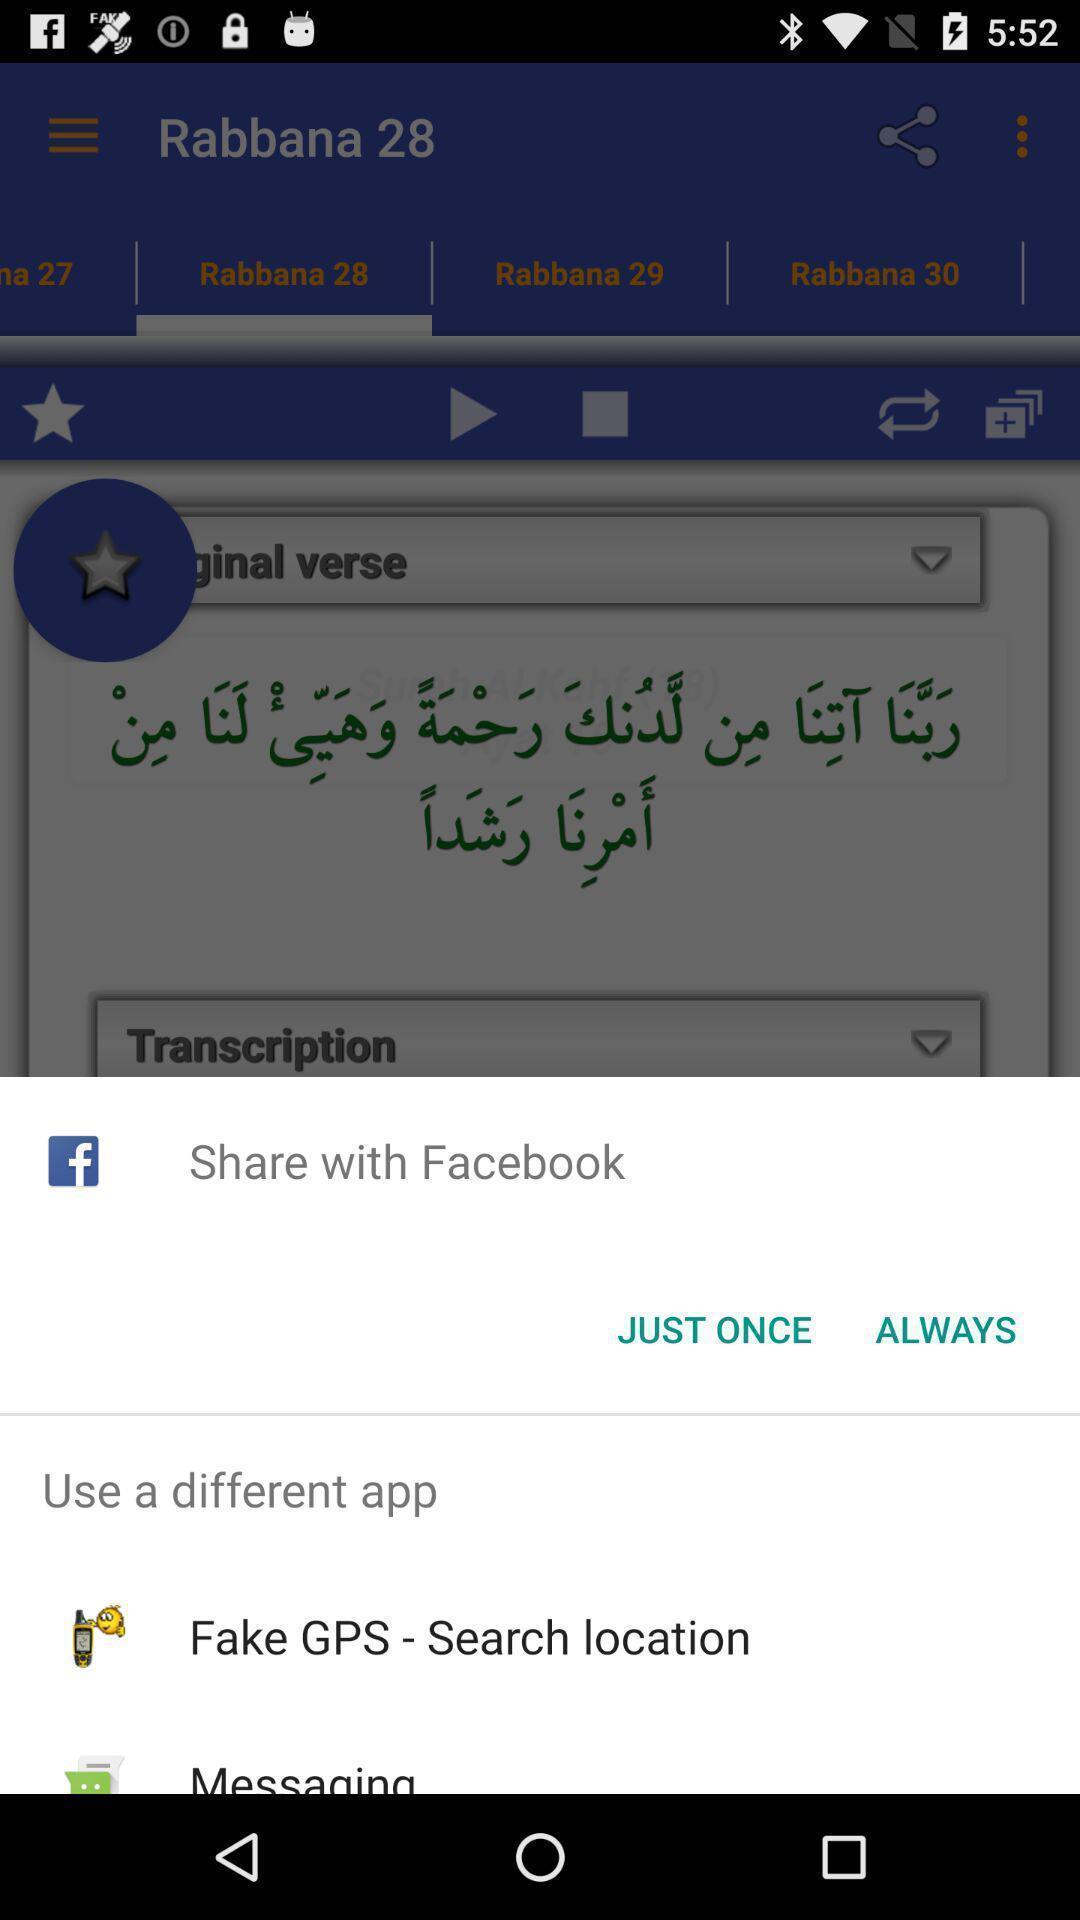Summarize the information in this screenshot. Screen shows share option with a social application. 